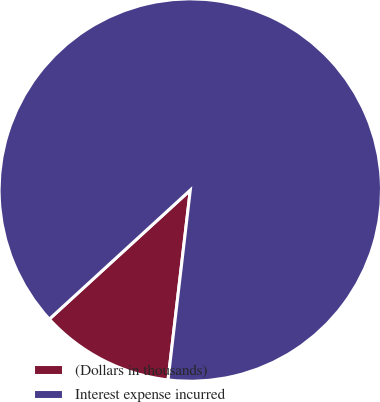<chart> <loc_0><loc_0><loc_500><loc_500><pie_chart><fcel>(Dollars in thousands)<fcel>Interest expense incurred<nl><fcel>11.34%<fcel>88.66%<nl></chart> 